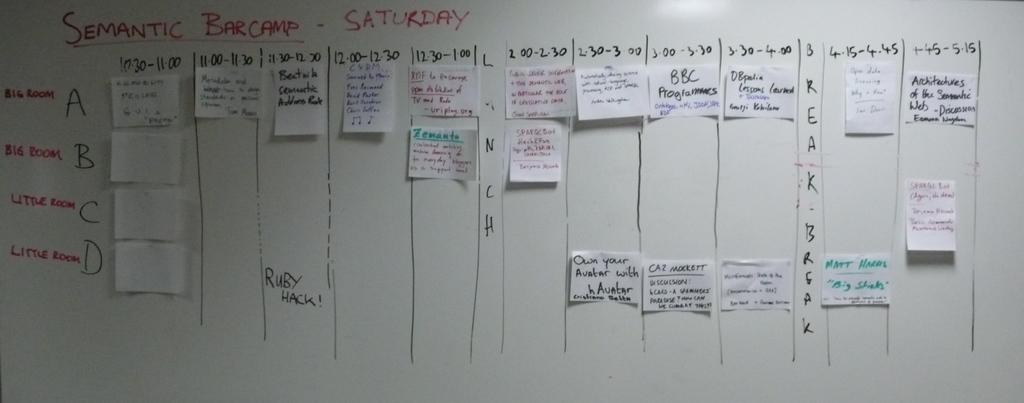What is the title of this ?
Your answer should be compact. Semantic barcamp. When does this take place?
Offer a very short reply. Saturday. 